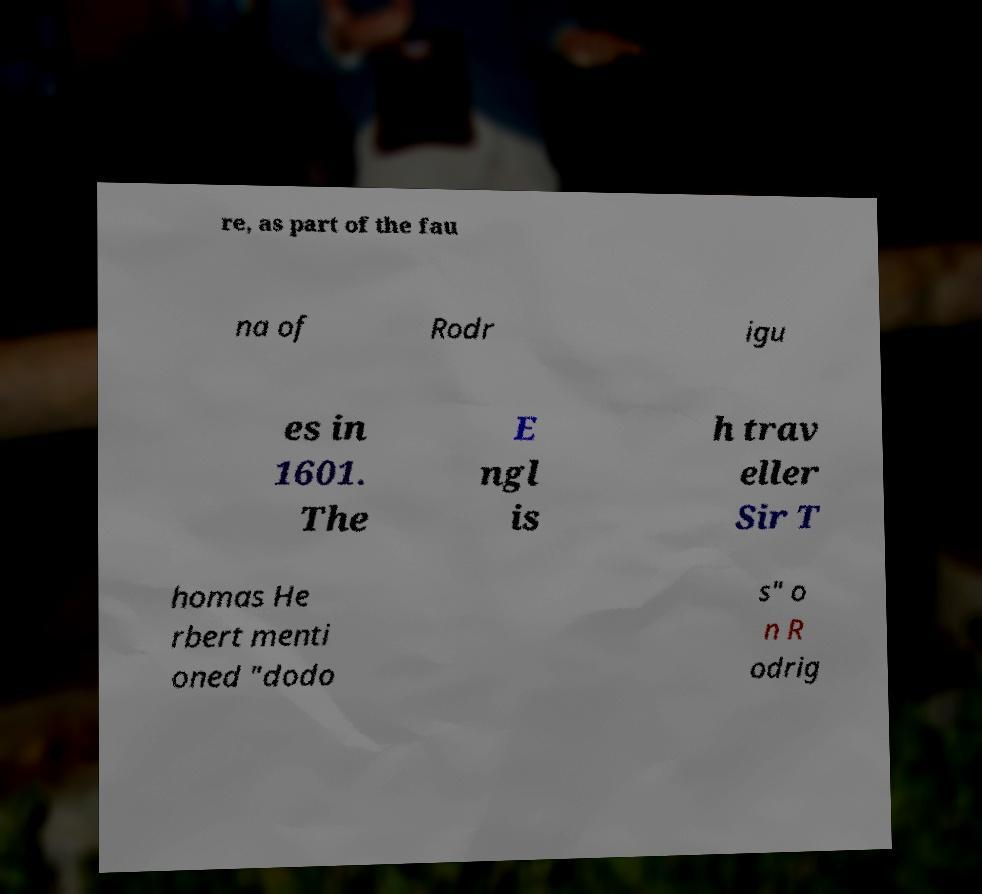Could you extract and type out the text from this image? re, as part of the fau na of Rodr igu es in 1601. The E ngl is h trav eller Sir T homas He rbert menti oned "dodo s" o n R odrig 